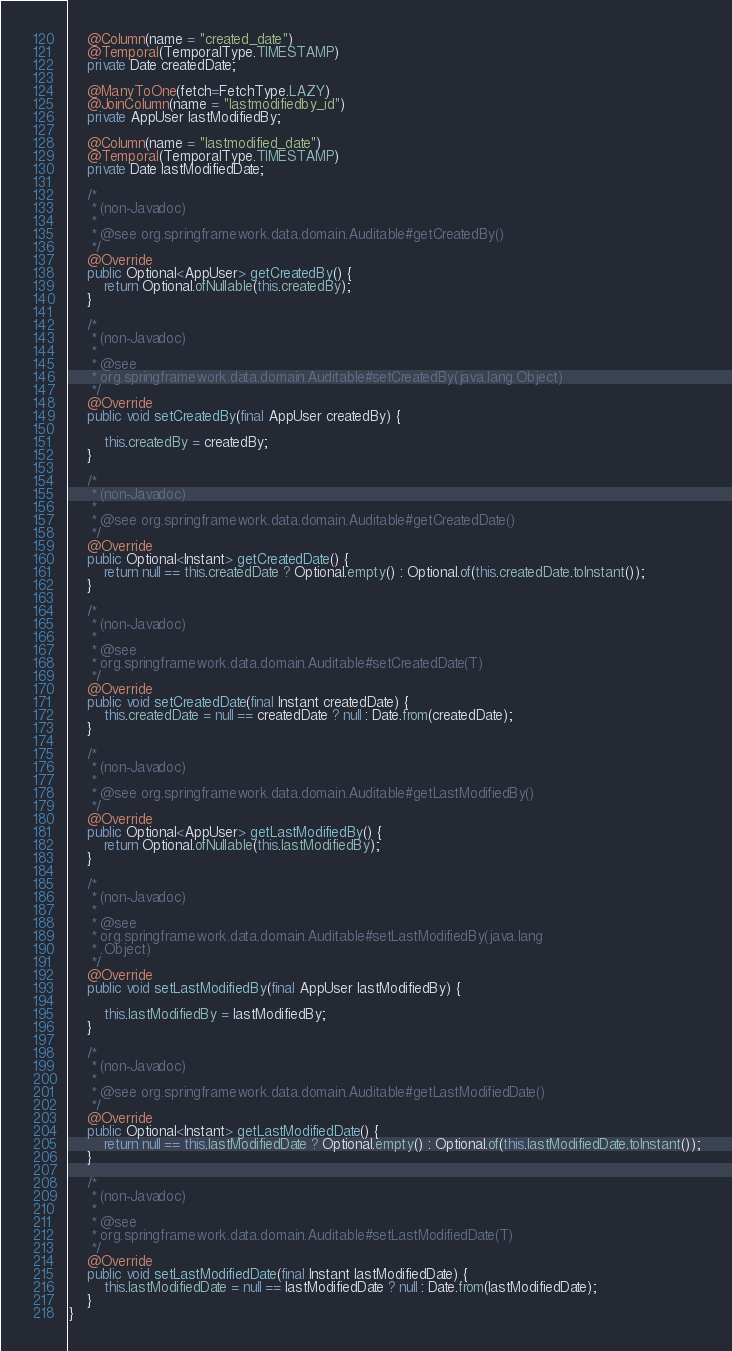<code> <loc_0><loc_0><loc_500><loc_500><_Java_>    @Column(name = "created_date")
    @Temporal(TemporalType.TIMESTAMP)
    private Date createdDate;

    @ManyToOne(fetch=FetchType.LAZY)
    @JoinColumn(name = "lastmodifiedby_id")
    private AppUser lastModifiedBy;

    @Column(name = "lastmodified_date")
    @Temporal(TemporalType.TIMESTAMP)
    private Date lastModifiedDate;

    /*
     * (non-Javadoc)
     *
     * @see org.springframework.data.domain.Auditable#getCreatedBy()
     */
    @Override
    public Optional<AppUser> getCreatedBy() {
        return Optional.ofNullable(this.createdBy);
    }

    /*
     * (non-Javadoc)
     *
     * @see
     * org.springframework.data.domain.Auditable#setCreatedBy(java.lang.Object)
     */
    @Override
    public void setCreatedBy(final AppUser createdBy) {

        this.createdBy = createdBy;
    }

    /*
     * (non-Javadoc)
     *
     * @see org.springframework.data.domain.Auditable#getCreatedDate()
     */
    @Override
    public Optional<Instant> getCreatedDate() {
        return null == this.createdDate ? Optional.empty() : Optional.of(this.createdDate.toInstant());
    }

    /*
     * (non-Javadoc)
     *
     * @see
     * org.springframework.data.domain.Auditable#setCreatedDate(T)
     */
    @Override
    public void setCreatedDate(final Instant createdDate) {
        this.createdDate = null == createdDate ? null : Date.from(createdDate);
    }

    /*
     * (non-Javadoc)
     *
     * @see org.springframework.data.domain.Auditable#getLastModifiedBy()
     */
    @Override
    public Optional<AppUser> getLastModifiedBy() {
        return Optional.ofNullable(this.lastModifiedBy);
    }

    /*
     * (non-Javadoc)
     *
     * @see
     * org.springframework.data.domain.Auditable#setLastModifiedBy(java.lang
     * .Object)
     */
    @Override
    public void setLastModifiedBy(final AppUser lastModifiedBy) {

        this.lastModifiedBy = lastModifiedBy;
    }

    /*
     * (non-Javadoc)
     *
     * @see org.springframework.data.domain.Auditable#getLastModifiedDate()
     */
    @Override
    public Optional<Instant> getLastModifiedDate() {
        return null == this.lastModifiedDate ? Optional.empty() : Optional.of(this.lastModifiedDate.toInstant());
    }

    /*
     * (non-Javadoc)
     *
     * @see
     * org.springframework.data.domain.Auditable#setLastModifiedDate(T)
     */
    @Override
    public void setLastModifiedDate(final Instant lastModifiedDate) {
        this.lastModifiedDate = null == lastModifiedDate ? null : Date.from(lastModifiedDate);
    }
}
</code> 